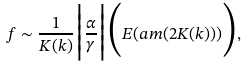Convert formula to latex. <formula><loc_0><loc_0><loc_500><loc_500>f \sim \frac { 1 } { K ( k ) } \Big { | } \frac { \alpha } { \gamma } \Big { | } \Big { ( } E ( a m ( 2 K ( k ) ) ) \Big { ) } ,</formula> 